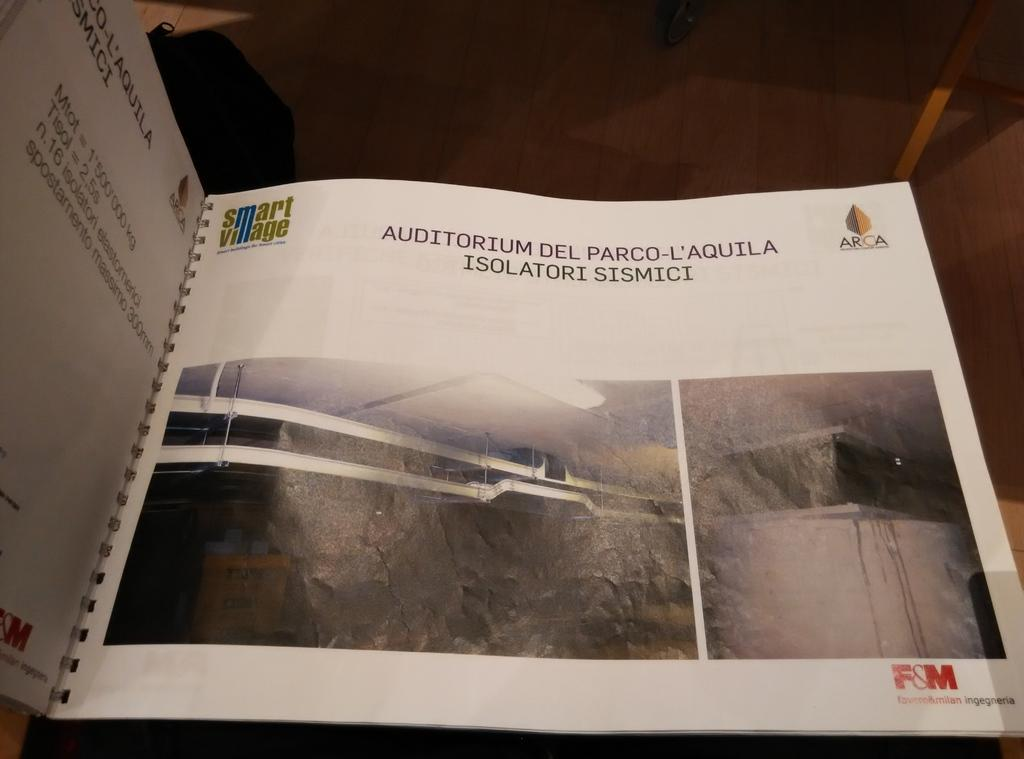Provide a one-sentence caption for the provided image. The page of a spiral-bound book, which is about an Auditorium and written in Spanish. 